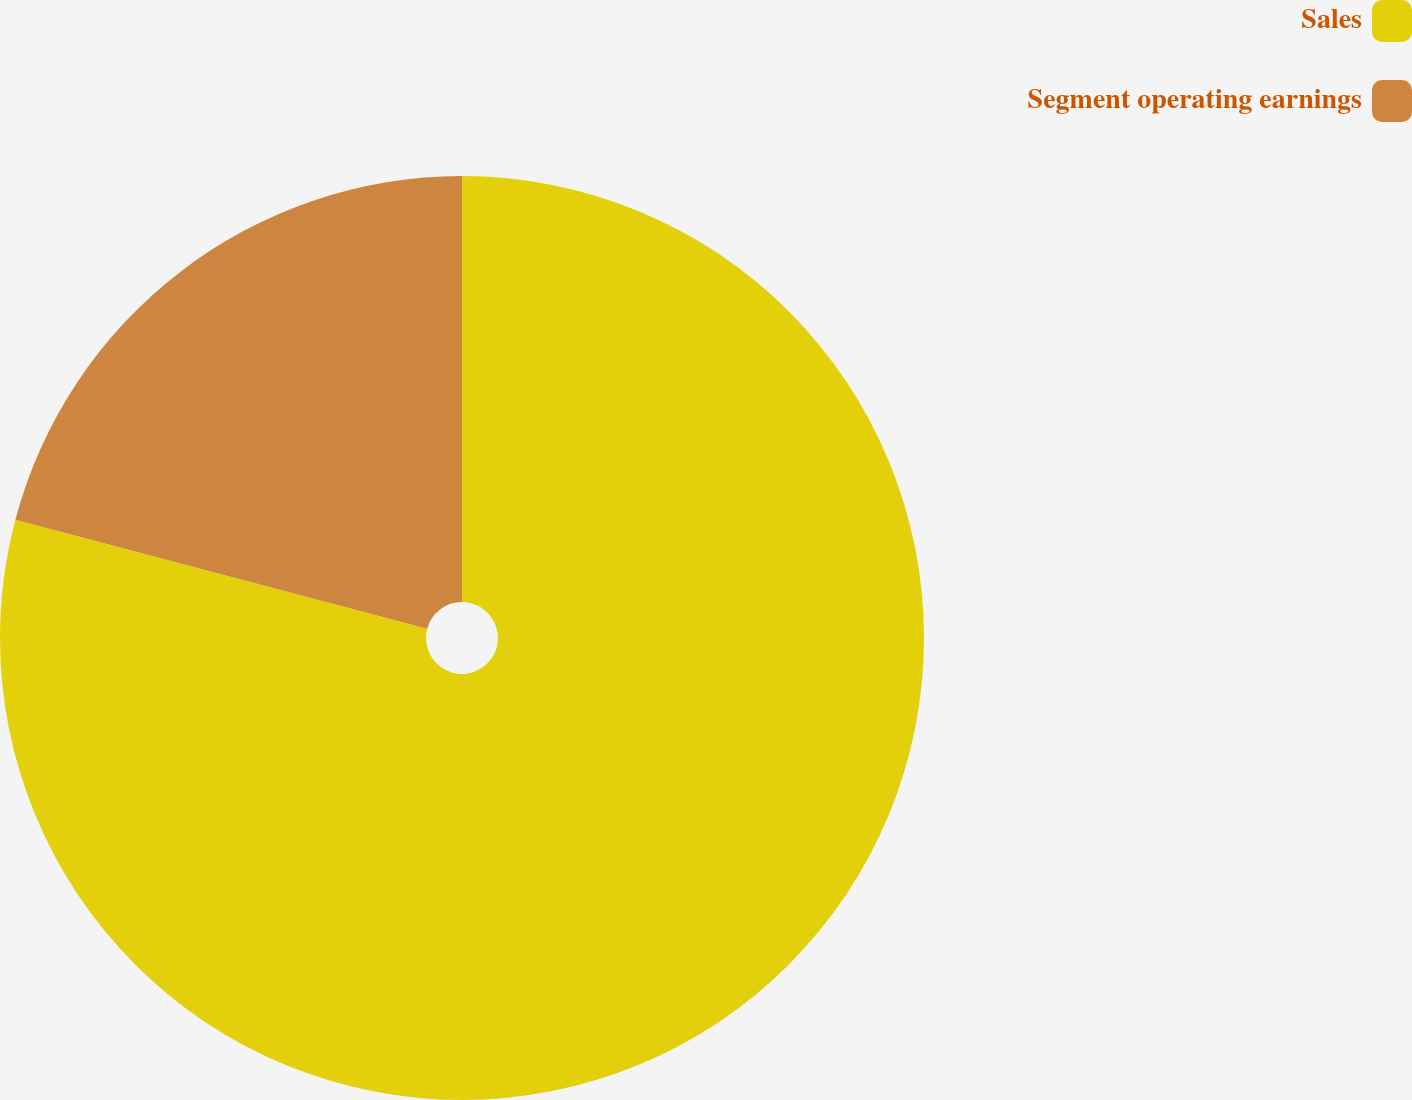Convert chart. <chart><loc_0><loc_0><loc_500><loc_500><pie_chart><fcel>Sales<fcel>Segment operating earnings<nl><fcel>79.12%<fcel>20.88%<nl></chart> 